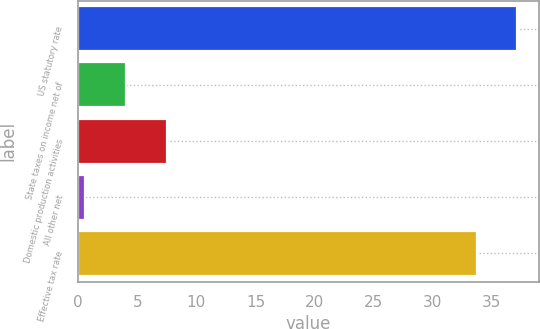<chart> <loc_0><loc_0><loc_500><loc_500><bar_chart><fcel>US statutory rate<fcel>State taxes on income net of<fcel>Domestic production activities<fcel>All other net<fcel>Effective tax rate<nl><fcel>37.14<fcel>4.04<fcel>7.48<fcel>0.6<fcel>33.7<nl></chart> 